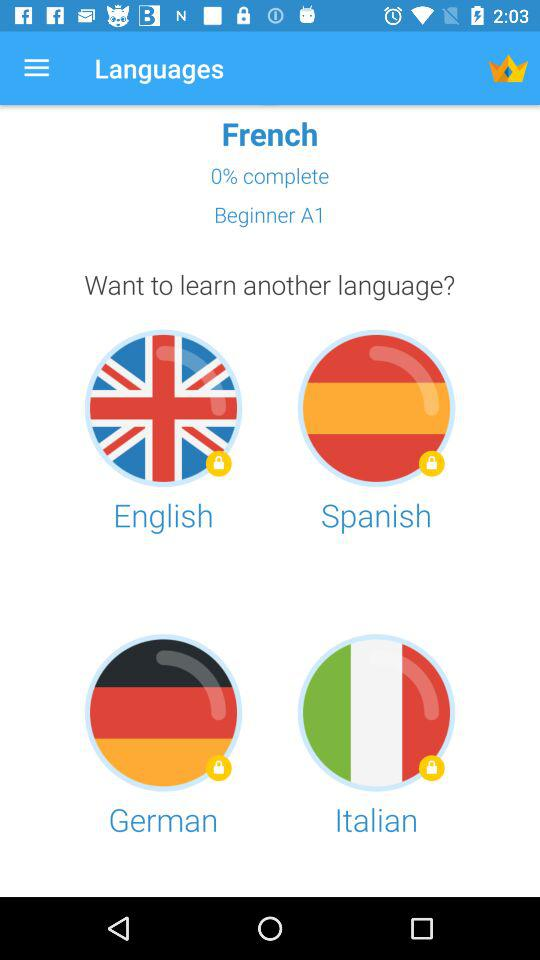What languages are there to complete the course? The languages are "English", "Spanish", "German", and "Italian". 